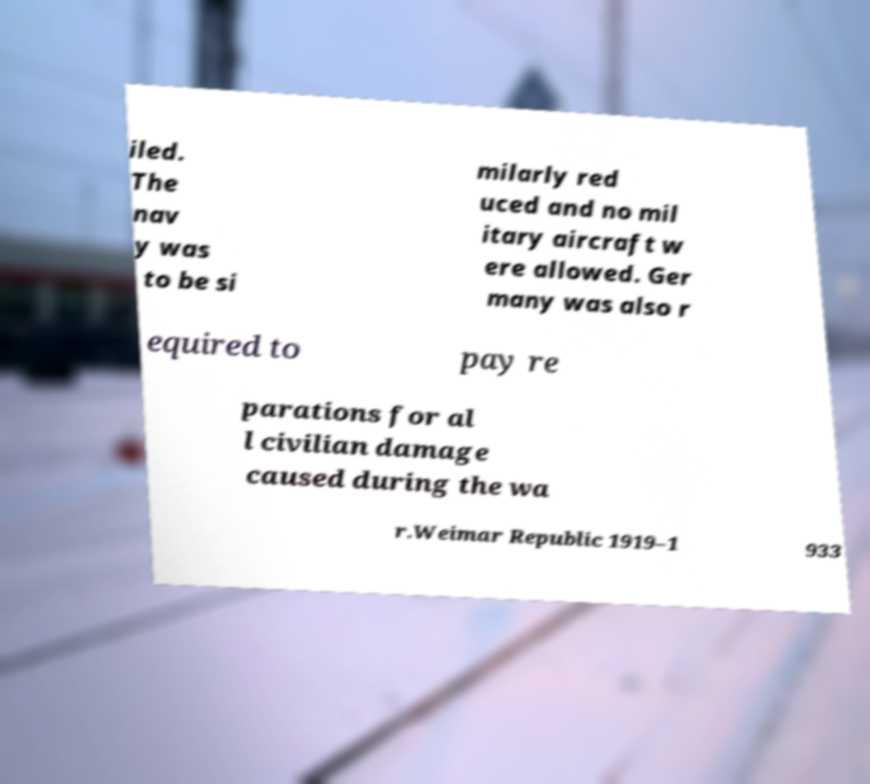Can you accurately transcribe the text from the provided image for me? iled. The nav y was to be si milarly red uced and no mil itary aircraft w ere allowed. Ger many was also r equired to pay re parations for al l civilian damage caused during the wa r.Weimar Republic 1919–1 933 